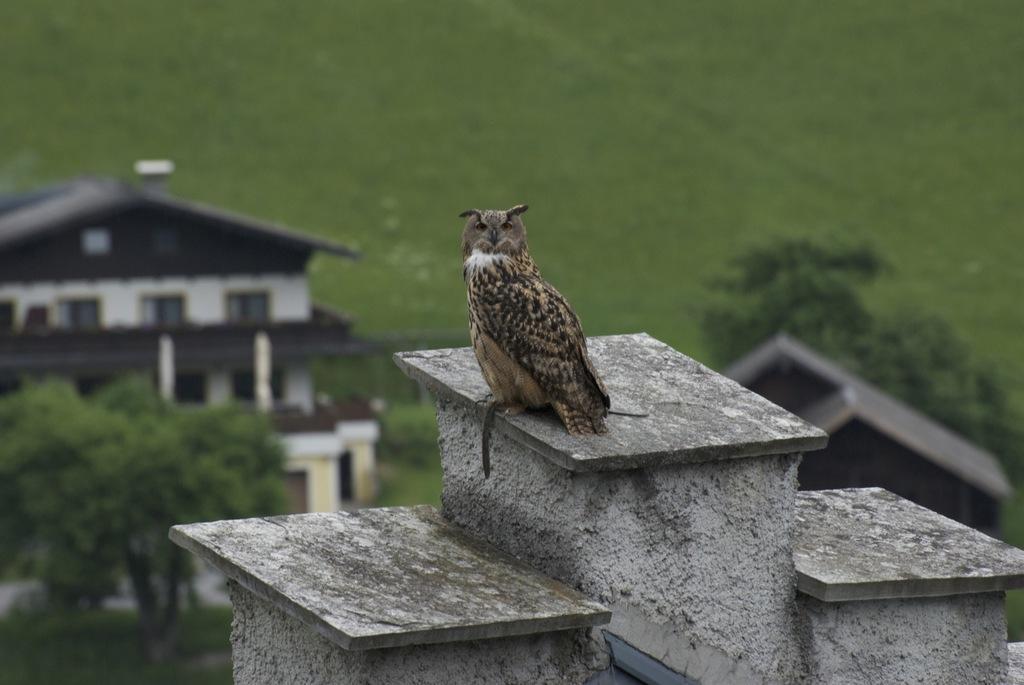In one or two sentences, can you explain what this image depicts? In the image we can see there is an owl bird standing on the building and behind there are trees and there is a building. There is a ground covered with grass and background of the image is little blurred. 